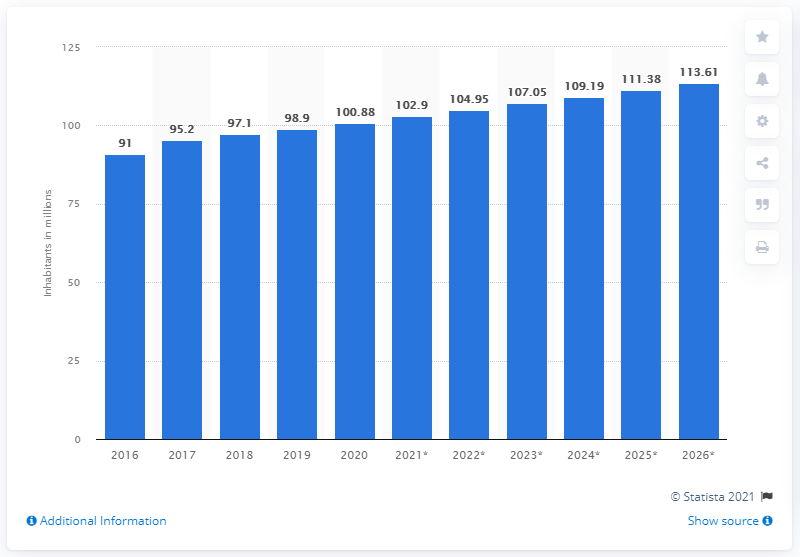Identify some key points in this picture. The estimated population of Egypt by 2026 is 113.61 million. In 2020, the population of Egypt was 100.88 million. 